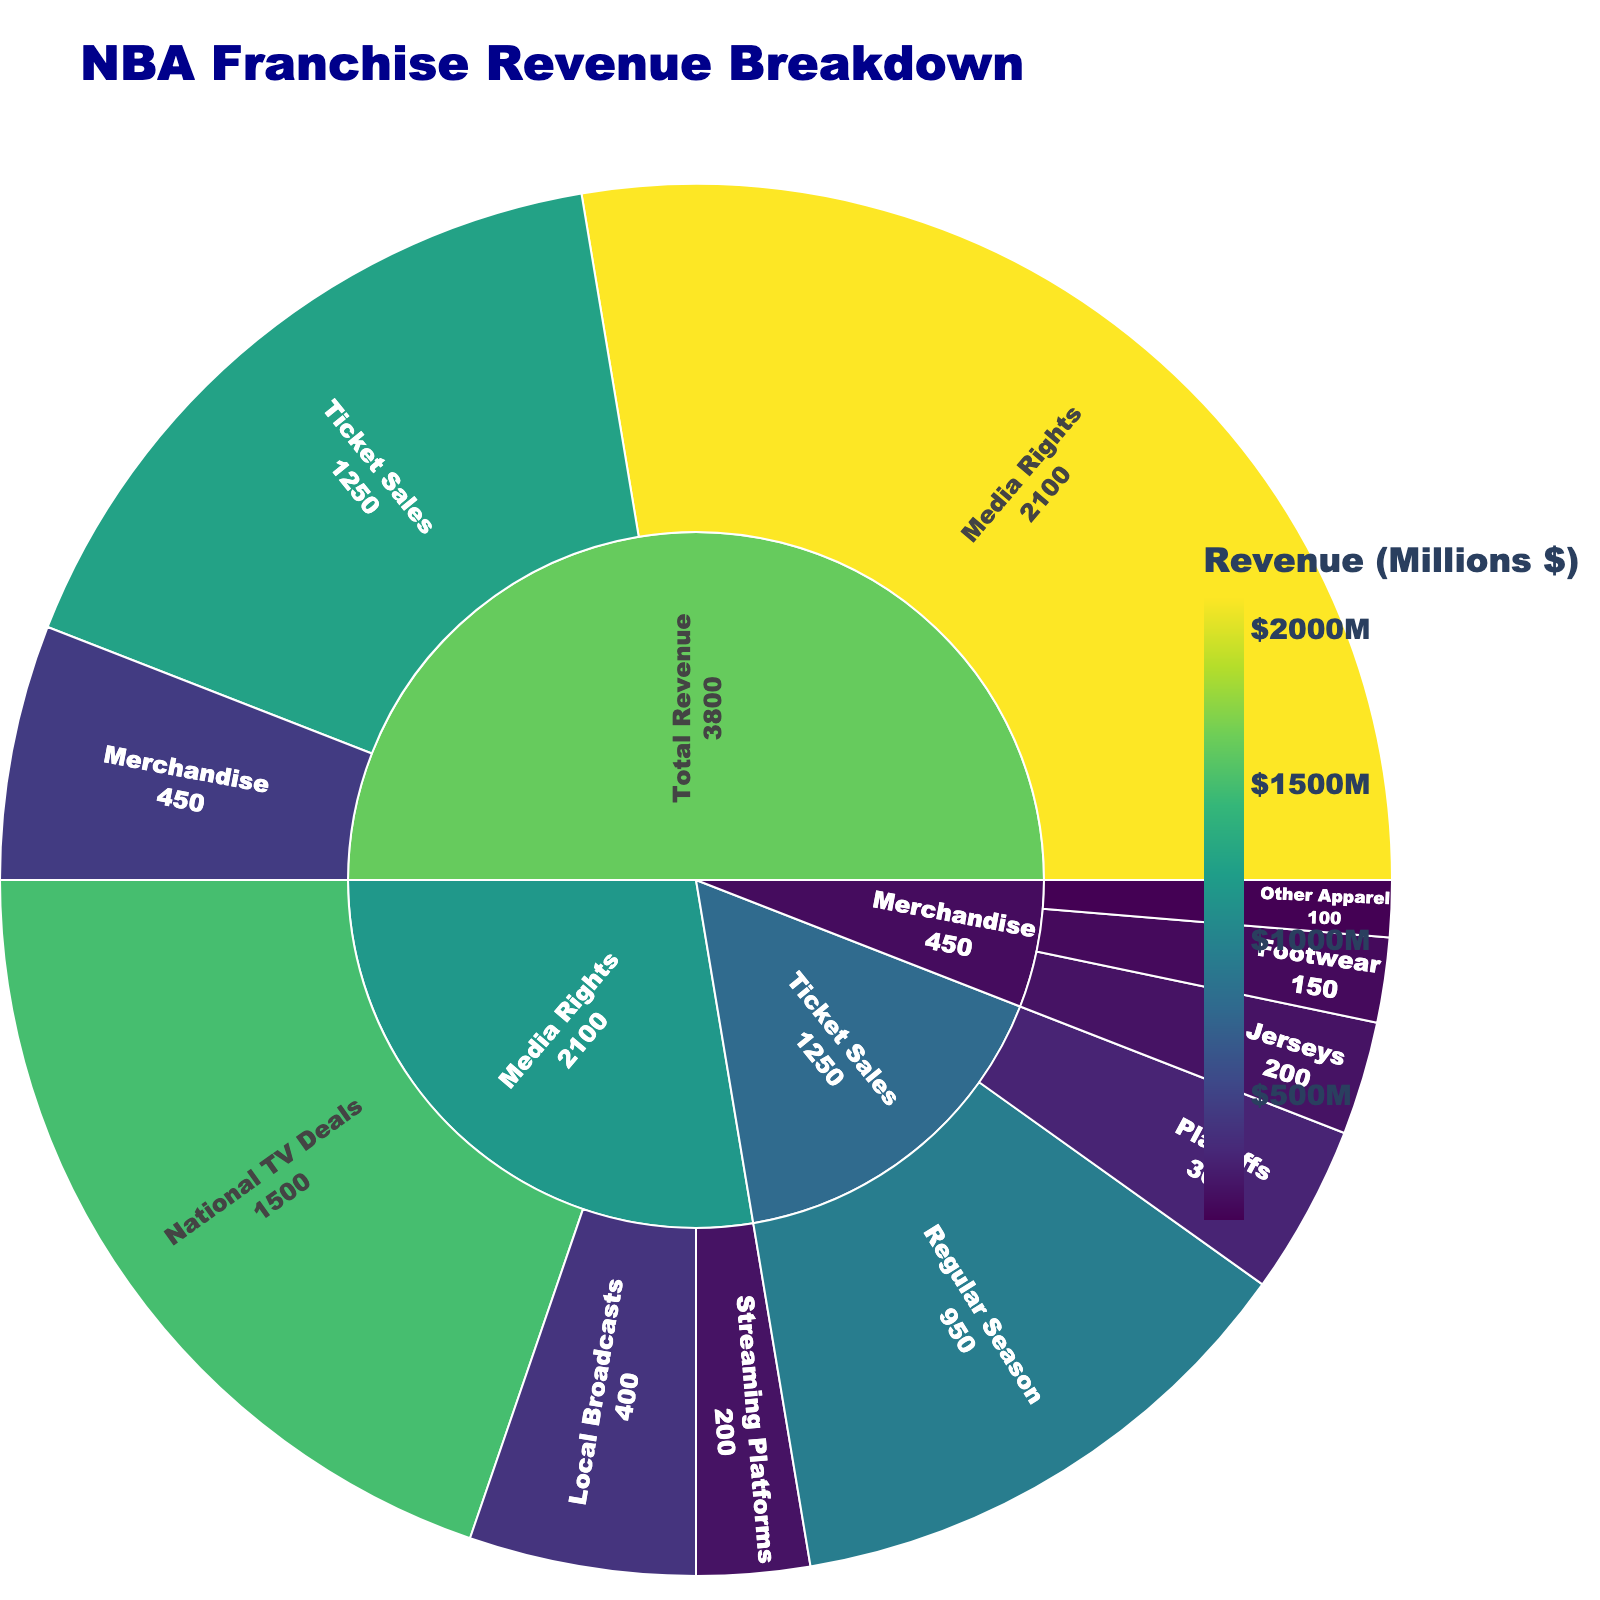What is the title of the Sunburst Plot? The title is usually prominently displayed at the top of the figure, giving a summary of what the plot represents. The title in this case is "NBA Franchise Revenue Breakdown."
Answer: NBA Franchise Revenue Breakdown What are the three main categories of revenue breakdown in the plot? The Sunburst Plot shows the main categories at the first level of decomposition from the center. Here, the main categories are 'Ticket Sales', 'Merchandise', and 'Media Rights.'
Answer: Ticket Sales, Merchandise, Media Rights Which revenue source contributes the most to the total revenue? By comparing the size and color intensity of the sections, 'Media Rights' is the largest and darkest segment, indicating it has the highest value.
Answer: Media Rights How much revenue is generated from Playoffs ticket sales? Look for the Playoffs segment under the Ticket Sales category, then check its value. The segment shows the revenue generated from Playoffs ticket sales is $300 million.
Answer: $300 million What is the combined revenue from Jerseys and Footwear? Adding the values of 'Jerseys' and 'Footwear' under Merchandise gives 200 + 150. Hence, the total combined revenue from these two sources is $350 million.
Answer: $350 million How does the revenue from Local Broadcasts compare to that from Streaming Platforms? By comparing the values of 'Local Broadcasts' and 'Streaming Platforms' under Media Rights, Local Broadcasts generate $400 million, and Streaming Platforms generate $200 million. $400 million is greater than $200 million.
Answer: Local Broadcasts generate more revenue than Streaming Platforms What proportion of Media Rights revenue is from National TV Deals? National TV Deals revenue is $1500 million out of the total Media Rights revenue of $2100 million. The proportion is calculated as (1500/2100) * 100 = 71.43%.
Answer: 71.43% How does the revenue from Regular Season ticket sales compare to the total Ticket Sales revenue? Regular Season ticket sales revenue is $950 million. The total for Ticket Sales is $1250 million. The proportion is (950/1250) * 100 = 76%.
Answer: 76% What category has the smallest revenue generation, and what is its value? The smallest revenue-generating category can be found by comparing all segments. The 'Other Apparel' under Merchandise is the smallest segment with a revenue value of $100 million.
Answer: Other Apparel, $100 million What is the total revenue from the three categories combined? Sum the values of Ticket Sales, Merchandise, and Media Rights: 1250 + 450 + 2100 = $3800 million.
Answer: $3800 million 